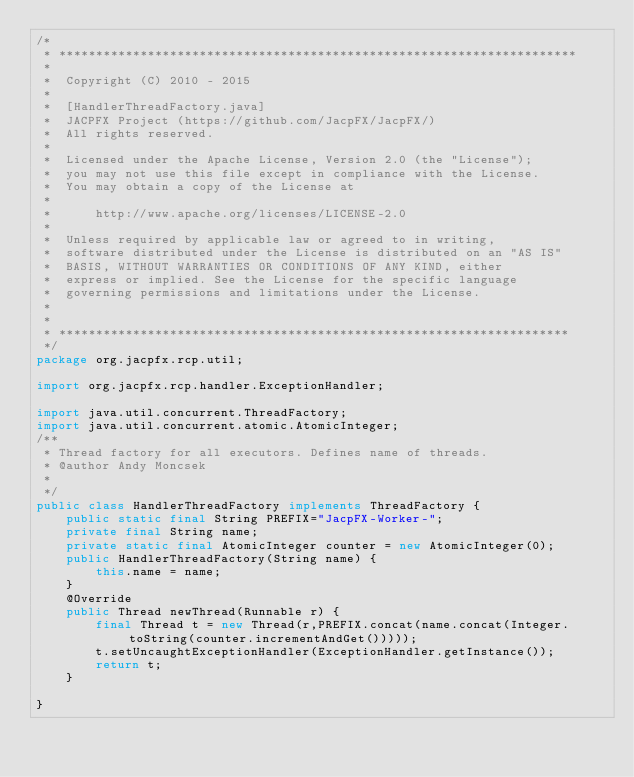<code> <loc_0><loc_0><loc_500><loc_500><_Java_>/*
 * **********************************************************************
 *
 *  Copyright (C) 2010 - 2015
 *
 *  [HandlerThreadFactory.java]
 *  JACPFX Project (https://github.com/JacpFX/JacpFX/)
 *  All rights reserved.
 *
 *  Licensed under the Apache License, Version 2.0 (the "License");
 *  you may not use this file except in compliance with the License.
 *  You may obtain a copy of the License at
 *
 *      http://www.apache.org/licenses/LICENSE-2.0
 *
 *  Unless required by applicable law or agreed to in writing,
 *  software distributed under the License is distributed on an "AS IS"
 *  BASIS, WITHOUT WARRANTIES OR CONDITIONS OF ANY KIND, either
 *  express or implied. See the License for the specific language
 *  governing permissions and limitations under the License.
 *
 *
 * *********************************************************************
 */
package org.jacpfx.rcp.util;

import org.jacpfx.rcp.handler.ExceptionHandler;

import java.util.concurrent.ThreadFactory;
import java.util.concurrent.atomic.AtomicInteger;
/**
 * Thread factory for all executors. Defines name of threads.
 * @author Andy Moncsek
 *
 */
public class HandlerThreadFactory implements ThreadFactory {
	public static final String PREFIX="JacpFX-Worker-";
	private final String name;
	private static final AtomicInteger counter = new AtomicInteger(0);
	public HandlerThreadFactory(String name) {
		this.name = name;
	}
	@Override
    public Thread newThread(Runnable r) {
        final Thread t = new Thread(r,PREFIX.concat(name.concat(Integer.toString(counter.incrementAndGet()))));
		t.setUncaughtExceptionHandler(ExceptionHandler.getInstance());
        return t;
	}

}
</code> 